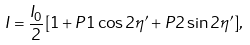<formula> <loc_0><loc_0><loc_500><loc_500>I = \frac { I _ { 0 } } { 2 } [ 1 + P 1 \cos 2 \eta ^ { \prime } + P 2 \sin 2 \eta ^ { \prime } ] ,</formula> 